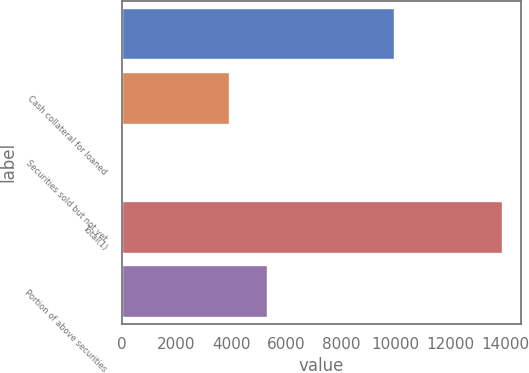Convert chart. <chart><loc_0><loc_0><loc_500><loc_500><bar_chart><ecel><fcel>Cash collateral for loaned<fcel>Securities sold but not yet<fcel>Total(1)<fcel>Portion of above securities<nl><fcel>9950<fcel>3929<fcel>9<fcel>13888<fcel>5316.9<nl></chart> 